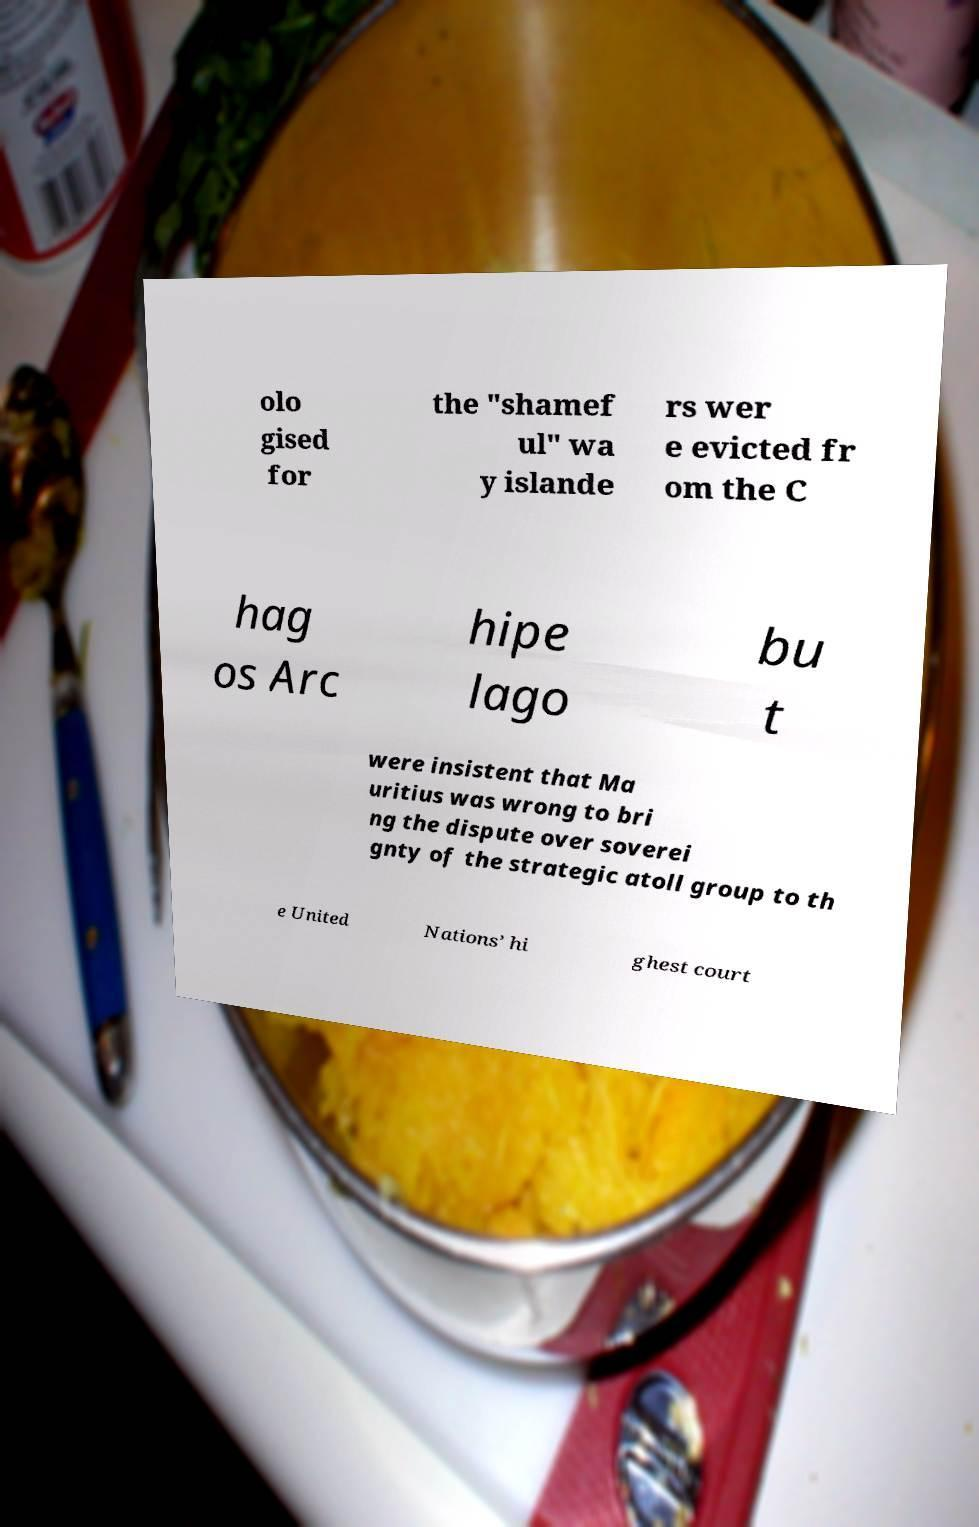I need the written content from this picture converted into text. Can you do that? olo gised for the "shamef ul" wa y islande rs wer e evicted fr om the C hag os Arc hipe lago bu t were insistent that Ma uritius was wrong to bri ng the dispute over soverei gnty of the strategic atoll group to th e United Nations’ hi ghest court 